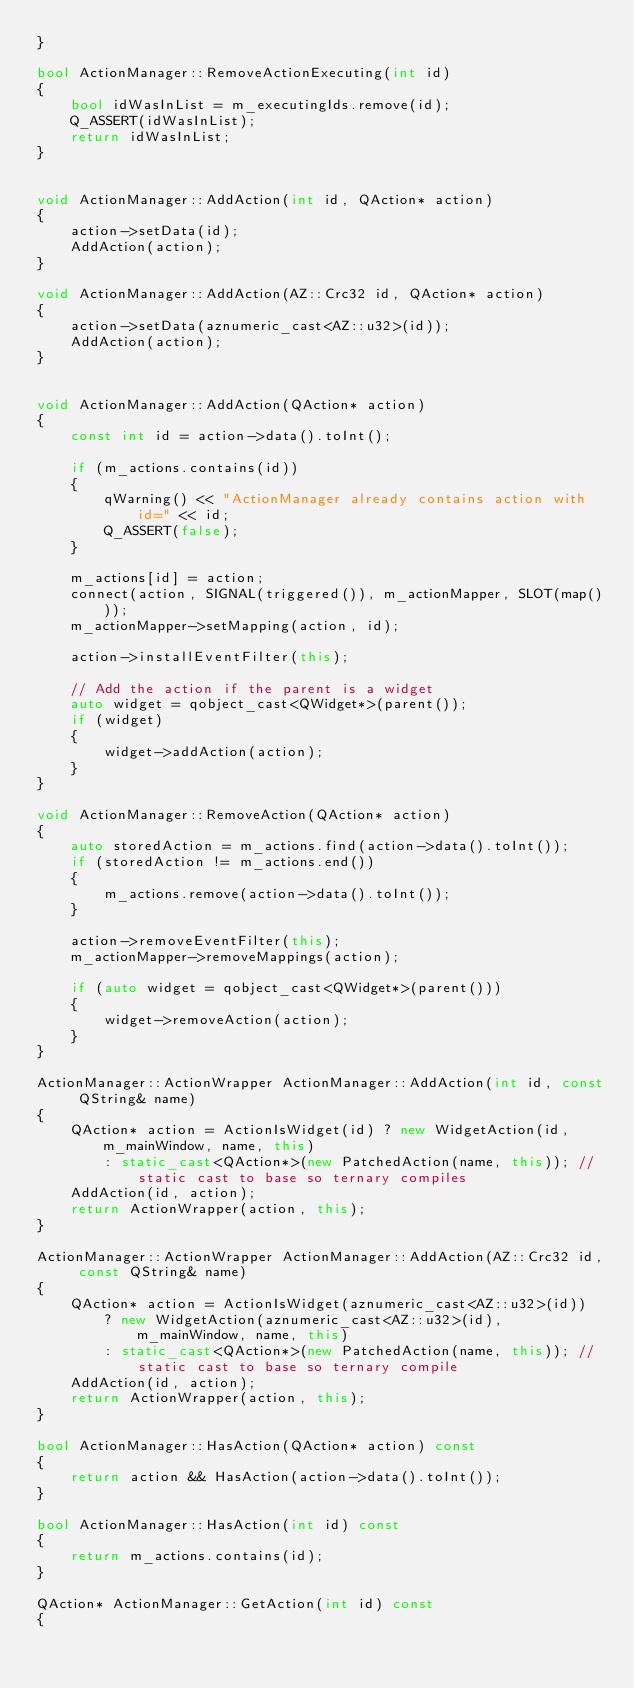<code> <loc_0><loc_0><loc_500><loc_500><_C++_>}

bool ActionManager::RemoveActionExecuting(int id)
{
    bool idWasInList = m_executingIds.remove(id);
    Q_ASSERT(idWasInList);
    return idWasInList;
}


void ActionManager::AddAction(int id, QAction* action)
{
    action->setData(id);
    AddAction(action);
}

void ActionManager::AddAction(AZ::Crc32 id, QAction* action)
{
    action->setData(aznumeric_cast<AZ::u32>(id));
    AddAction(action);
}


void ActionManager::AddAction(QAction* action)
{
    const int id = action->data().toInt();

    if (m_actions.contains(id))
    {
        qWarning() << "ActionManager already contains action with id=" << id;
        Q_ASSERT(false);
    }

    m_actions[id] = action;
    connect(action, SIGNAL(triggered()), m_actionMapper, SLOT(map()));
    m_actionMapper->setMapping(action, id);

    action->installEventFilter(this);

    // Add the action if the parent is a widget
    auto widget = qobject_cast<QWidget*>(parent());
    if (widget)
    {
        widget->addAction(action);
    }
}

void ActionManager::RemoveAction(QAction* action)
{
    auto storedAction = m_actions.find(action->data().toInt());
    if (storedAction != m_actions.end())
    {
        m_actions.remove(action->data().toInt());
    }

    action->removeEventFilter(this);
    m_actionMapper->removeMappings(action);

    if (auto widget = qobject_cast<QWidget*>(parent()))
    {
        widget->removeAction(action);
    }
}

ActionManager::ActionWrapper ActionManager::AddAction(int id, const QString& name)
{
    QAction* action = ActionIsWidget(id) ? new WidgetAction(id, m_mainWindow, name, this)
        : static_cast<QAction*>(new PatchedAction(name, this)); // static cast to base so ternary compiles
    AddAction(id, action);
    return ActionWrapper(action, this);
}

ActionManager::ActionWrapper ActionManager::AddAction(AZ::Crc32 id, const QString& name)
{
    QAction* action = ActionIsWidget(aznumeric_cast<AZ::u32>(id))
        ? new WidgetAction(aznumeric_cast<AZ::u32>(id), m_mainWindow, name, this)
        : static_cast<QAction*>(new PatchedAction(name, this)); // static cast to base so ternary compile
    AddAction(id, action);
    return ActionWrapper(action, this);
}

bool ActionManager::HasAction(QAction* action) const
{
    return action && HasAction(action->data().toInt());
}

bool ActionManager::HasAction(int id) const
{
    return m_actions.contains(id);
}

QAction* ActionManager::GetAction(int id) const
{</code> 